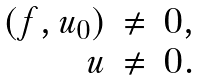<formula> <loc_0><loc_0><loc_500><loc_500>\begin{array} { r c l } ( f , u _ { 0 } ) & \neq & 0 , \\ u & \neq & 0 . \end{array}</formula> 